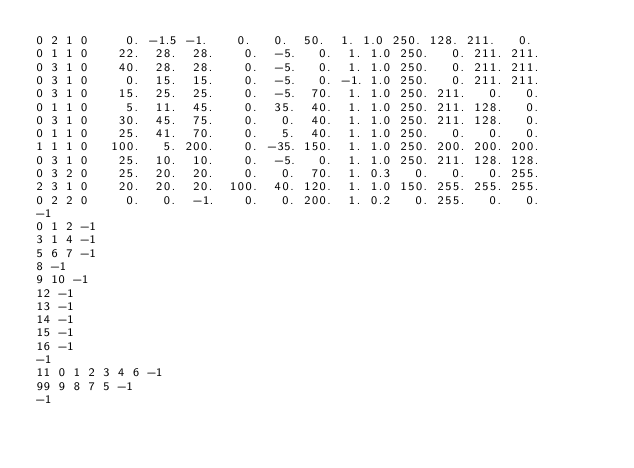Convert code to text. <code><loc_0><loc_0><loc_500><loc_500><_Scheme_>0 2 1 0     0. -1.5 -1.    0.   0.  50.  1. 1.0 250. 128. 211.   0.
0 1 1 0    22.  28.  28.    0.  -5.   0.  1. 1.0 250.   0. 211. 211.
0 3 1 0    40.  28.  28.    0.  -5.   0.  1. 1.0 250.   0. 211. 211.
0 3 1 0     0.  15.  15.    0.  -5.   0. -1. 1.0 250.   0. 211. 211.
0 3 1 0    15.  25.  25.    0.  -5.  70.  1. 1.0 250. 211.   0.   0.
0 1 1 0     5.  11.  45.    0.  35.  40.  1. 1.0 250. 211. 128.   0.
0 3 1 0    30.  45.  75.    0.   0.  40.  1. 1.0 250. 211. 128.   0.
0 1 1 0    25.  41.  70.    0.   5.  40.  1. 1.0 250.   0.   0.   0.
1 1 1 0   100.   5. 200.    0. -35. 150.  1. 1.0 250. 200. 200. 200.
0 3 1 0    25.  10.  10.    0.  -5.   0.  1. 1.0 250. 211. 128. 128.
0 3 2 0    25.  20.  20.    0.   0.  70.  1. 0.3   0.   0.   0. 255.
2 3 1 0	   20.  20.  20.  100.  40. 120.  1. 1.0 150. 255. 255. 255.
0 2 2 0     0.   0.  -1.    0.   0. 200.  1. 0.2   0. 255.   0.   0.     
-1
0 1 2 -1
3 1 4 -1
5 6 7 -1
8 -1
9 10 -1
12 -1
13 -1
14 -1
15 -1
16 -1
-1
11 0 1 2 3 4 6 -1
99 9 8 7 5 -1
-1
</code> 